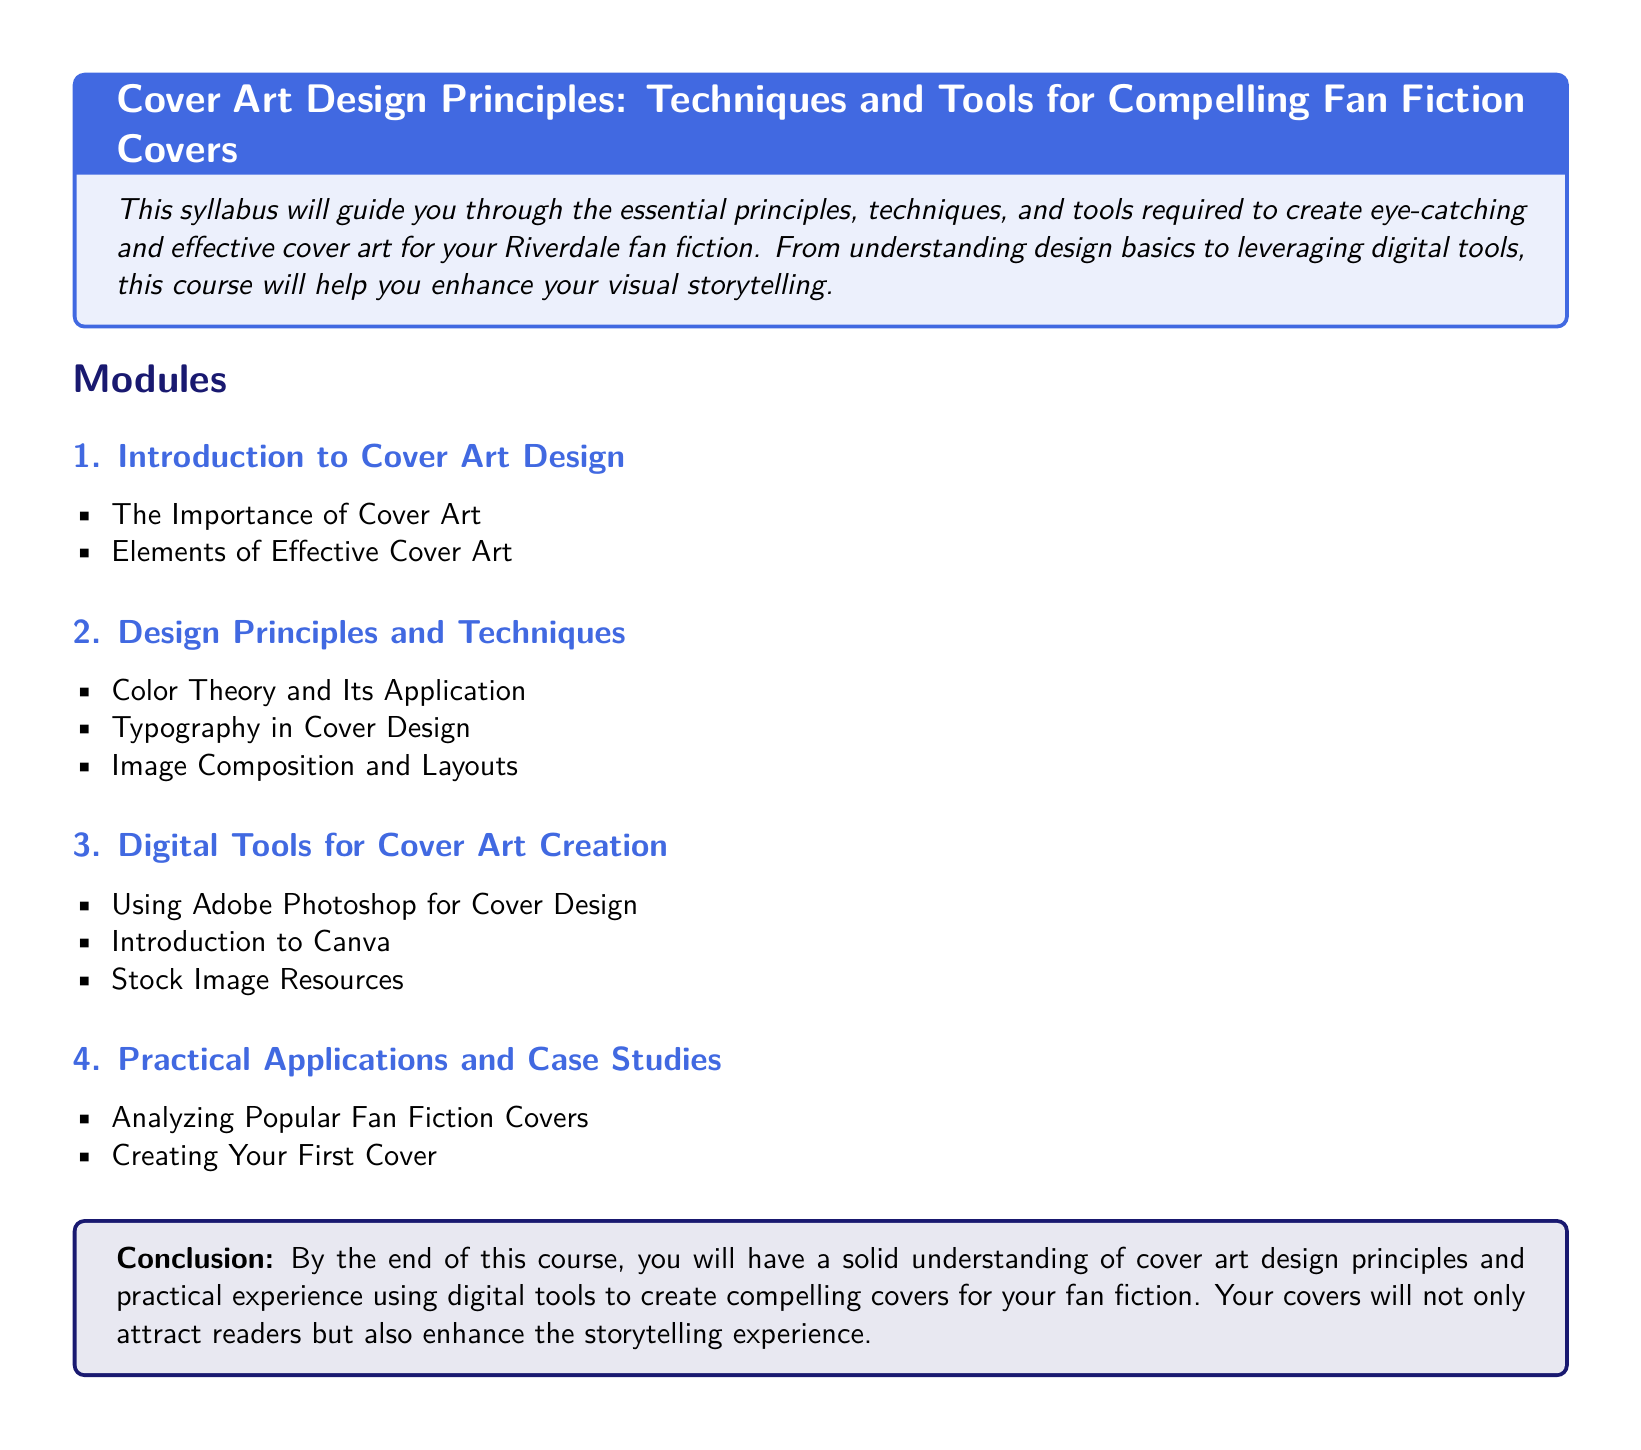What is the title of the syllabus? The title of the syllabus is given in the heading of the document.
Answer: Cover Art Design Principles: Techniques and Tools for Compelling Fan Fiction Covers How many modules are listed in the syllabus? The syllabus outlines the number of modules presented in the "Modules" section.
Answer: 4 Which software is mentioned for cover design? The syllabus lists digital tools that are specifically highlighted under "Digital Tools for Cover Art Creation."
Answer: Adobe Photoshop What color theory aspect is discussed in the syllabus? The particular topic related to color in cover art is found in the "Design Principles and Techniques" module.
Answer: Color Theory and Its Application What practical outcome should students expect at the end of the course? The conclusion summarizes the learning outcomes expected after completing the course.
Answer: Solid understanding of cover art design principles Which item is included in the Practical Applications module? The syllabus provides specific examples in the "Practical Applications and Case Studies" section related to fan fiction covers.
Answer: Analyzing Popular Fan Fiction Covers What font is used in the syllabus document? The use of a specific font is stated in the document's settings.
Answer: Comic Sans MS What is the primary focus of the syllabus? The introductory section states the overall goal of the syllabus and the intended audience.
Answer: Eye-catching and effective cover art for fan fiction 